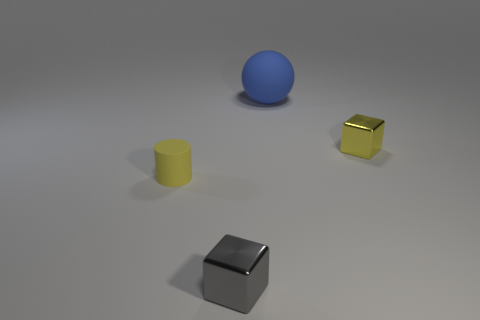What colors are the objects in the image? The colors of the objects are blue for the large sphere, yellow for the cylinder, gold for the cube, and silver for the smaller cube. 